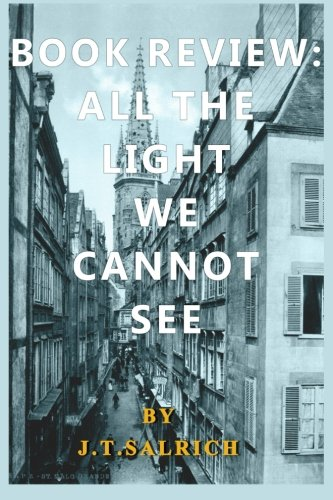Describe the setting shown on the cover of the book? The cover of the book features a historical urban setting, likely around the mid-20th century, depicting an old European city with narrow streets and tall, closely-set buildings. 